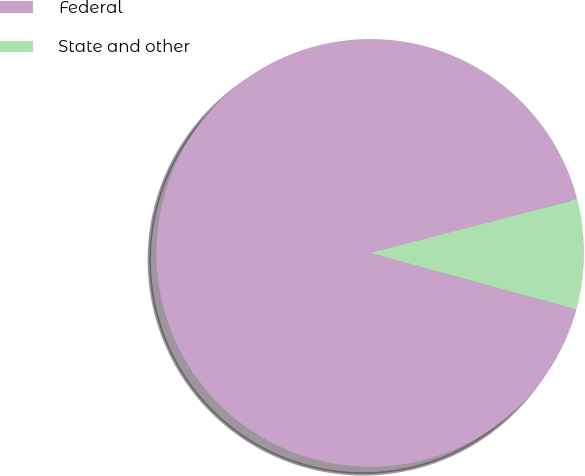<chart> <loc_0><loc_0><loc_500><loc_500><pie_chart><fcel>Federal<fcel>State and other<nl><fcel>91.72%<fcel>8.28%<nl></chart> 